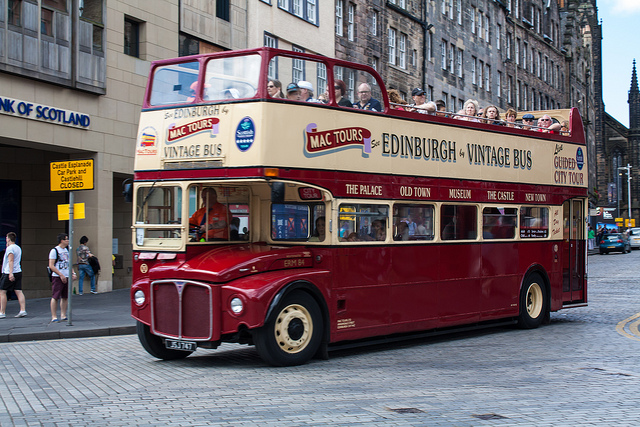Please transcribe the text in this image. EDINBURGH VINTAGE BUS MAC SCOTLAND OF CITY GUIDED CASTLE MUSEUM OLD PALACE THE 4 TOURS VINTAGE BUS MAC TOURS CLOSED NK 